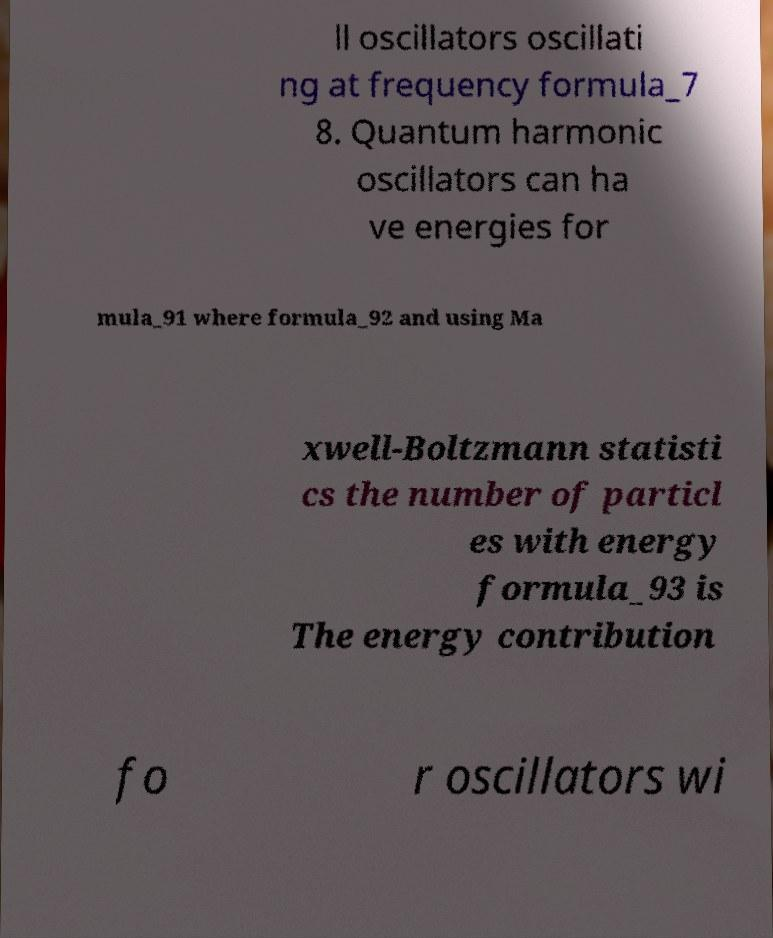Can you accurately transcribe the text from the provided image for me? ll oscillators oscillati ng at frequency formula_7 8. Quantum harmonic oscillators can ha ve energies for mula_91 where formula_92 and using Ma xwell-Boltzmann statisti cs the number of particl es with energy formula_93 is The energy contribution fo r oscillators wi 